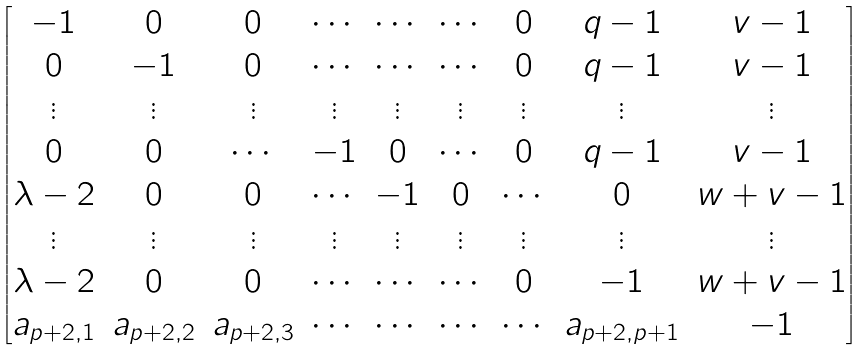<formula> <loc_0><loc_0><loc_500><loc_500>\begin{bmatrix} - 1 & 0 & 0 & \cdots & \cdots & \cdots & 0 & q - 1 & v - 1 \\ 0 & - 1 & 0 & \cdots & \cdots & \cdots & 0 & q - 1 & v - 1 \\ \vdots & \vdots & \vdots & \vdots & \vdots & \vdots & \vdots & \vdots & \vdots \\ 0 & 0 & \cdots & - 1 & 0 & \cdots & 0 & q - 1 & v - 1 \\ \lambda - 2 & 0 & 0 & \cdots & - 1 & 0 & \cdots & 0 & w + v - 1 \\ \vdots & \vdots & \vdots & \vdots & \vdots & \vdots & \vdots & \vdots & \vdots \\ \lambda - 2 & 0 & 0 & \cdots & \cdots & \cdots & 0 & - 1 & w + v - 1 \\ a _ { p + 2 , 1 } & a _ { p + 2 , 2 } & a _ { p + 2 , 3 } & \cdots & \cdots & \cdots & \cdots & a _ { p + 2 , p + 1 } & - 1 \end{bmatrix}</formula> 